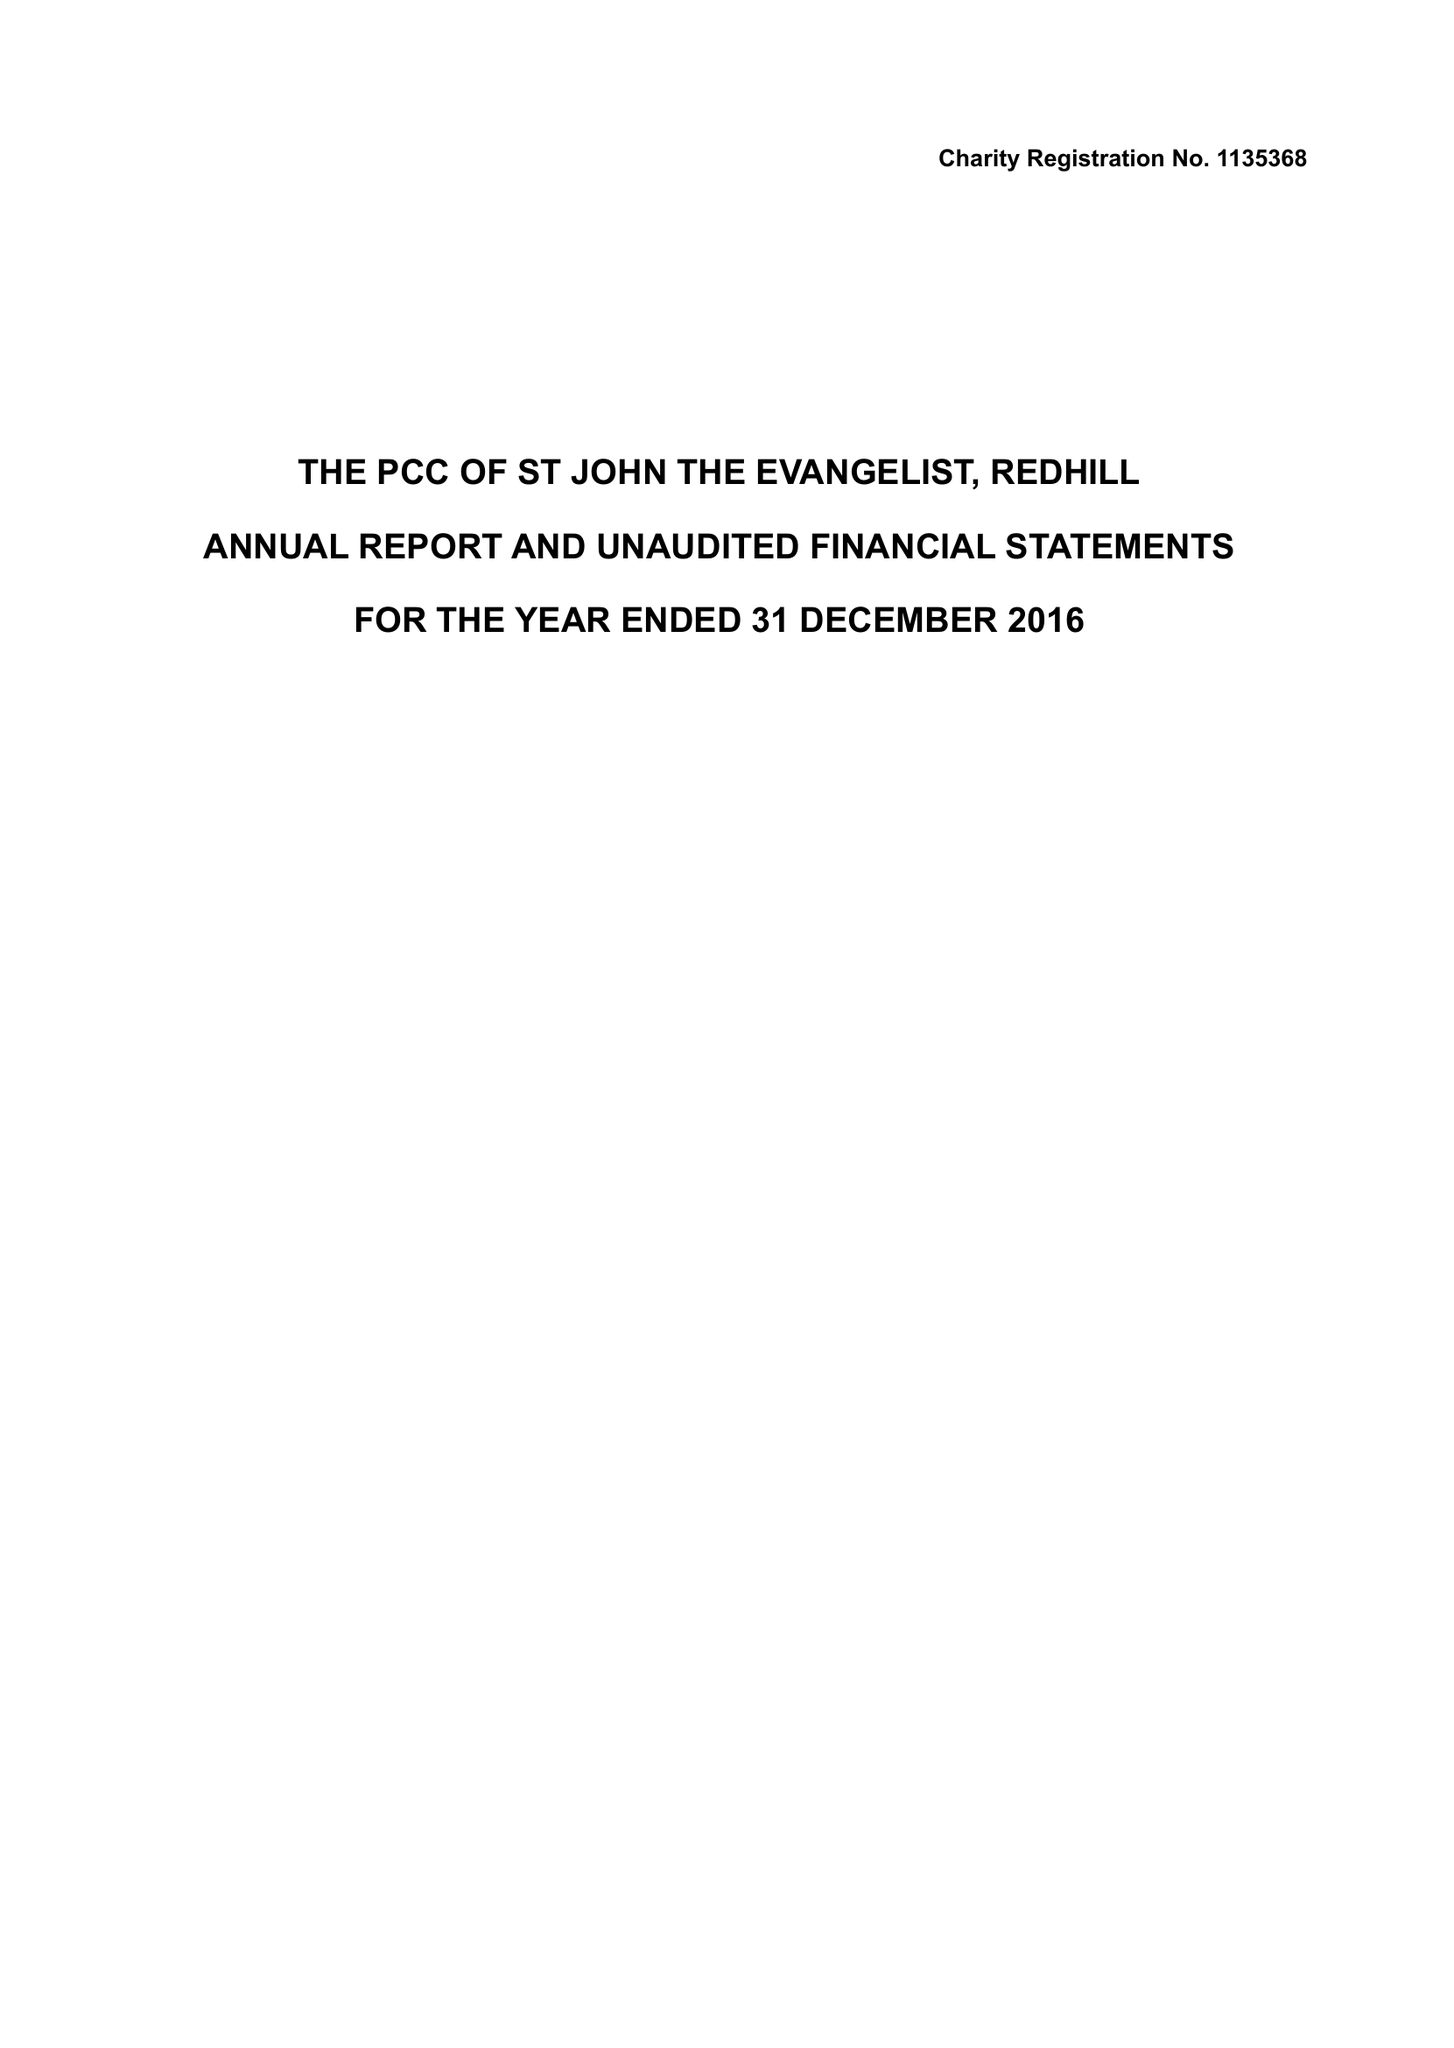What is the value for the report_date?
Answer the question using a single word or phrase. 2016-12-31 